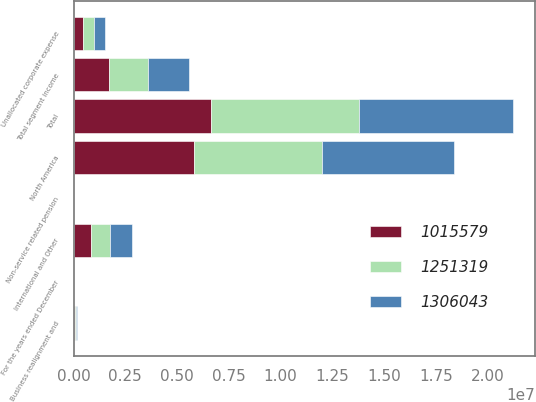<chart> <loc_0><loc_0><loc_500><loc_500><stacked_bar_chart><ecel><fcel>For the years ended December<fcel>North America<fcel>International and Other<fcel>Total<fcel>Total segment income<fcel>Unallocated corporate expense<fcel>Business realignment and<fcel>Non-service related pension<nl><fcel>1.30604e+06<fcel>2014<fcel>6.35273e+06<fcel>1.06904e+06<fcel>7.42177e+06<fcel>1.95621e+06<fcel>503407<fcel>50190<fcel>1834<nl><fcel>1.25132e+06<fcel>2013<fcel>6.20012e+06<fcel>945961<fcel>7.14608e+06<fcel>1.90722e+06<fcel>533506<fcel>19085<fcel>10885<nl><fcel>1.01558e+06<fcel>2012<fcel>5.81264e+06<fcel>831613<fcel>6.64425e+06<fcel>1.70751e+06<fcel>478645<fcel>83767<fcel>20572<nl></chart> 